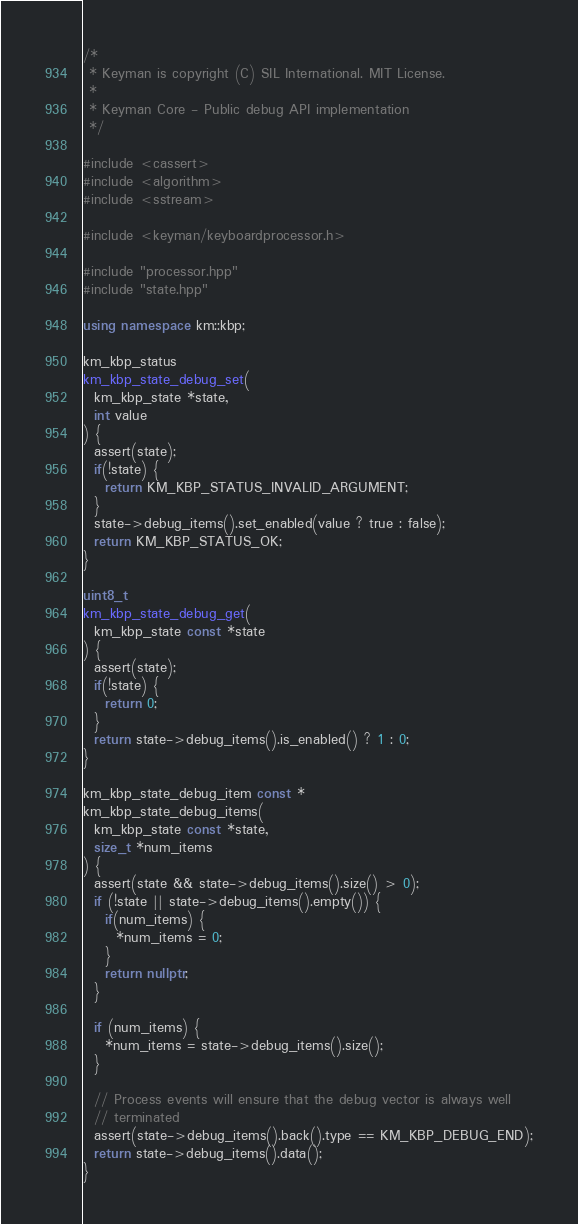<code> <loc_0><loc_0><loc_500><loc_500><_C++_>/*
 * Keyman is copyright (C) SIL International. MIT License.
 *
 * Keyman Core - Public debug API implementation
 */

#include <cassert>
#include <algorithm>
#include <sstream>

#include <keyman/keyboardprocessor.h>

#include "processor.hpp"
#include "state.hpp"

using namespace km::kbp;

km_kbp_status
km_kbp_state_debug_set(
  km_kbp_state *state,
  int value
) {
  assert(state);
  if(!state) {
    return KM_KBP_STATUS_INVALID_ARGUMENT;
  }
  state->debug_items().set_enabled(value ? true : false);
  return KM_KBP_STATUS_OK;
}

uint8_t
km_kbp_state_debug_get(
  km_kbp_state const *state
) {
  assert(state);
  if(!state) {
    return 0;
  }
  return state->debug_items().is_enabled() ? 1 : 0;
}

km_kbp_state_debug_item const *
km_kbp_state_debug_items(
  km_kbp_state const *state,
  size_t *num_items
) {
  assert(state && state->debug_items().size() > 0);
  if (!state || state->debug_items().empty()) {
    if(num_items) {
      *num_items = 0;
    }
    return nullptr;
  }

  if (num_items) {
    *num_items = state->debug_items().size();
  }

  // Process events will ensure that the debug vector is always well
  // terminated
  assert(state->debug_items().back().type == KM_KBP_DEBUG_END);
  return state->debug_items().data();
}
</code> 